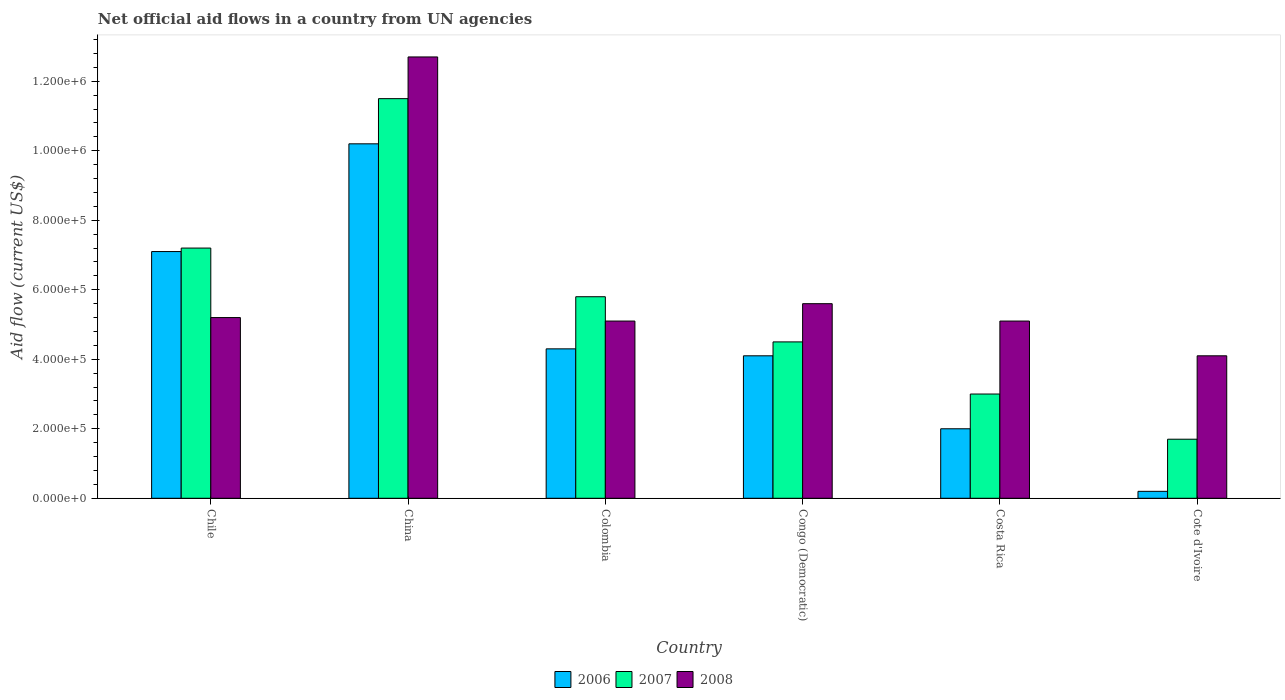Are the number of bars per tick equal to the number of legend labels?
Offer a terse response. Yes. What is the label of the 6th group of bars from the left?
Provide a succinct answer. Cote d'Ivoire. What is the net official aid flow in 2007 in Congo (Democratic)?
Your answer should be compact. 4.50e+05. Across all countries, what is the maximum net official aid flow in 2007?
Your response must be concise. 1.15e+06. In which country was the net official aid flow in 2007 minimum?
Keep it short and to the point. Cote d'Ivoire. What is the total net official aid flow in 2006 in the graph?
Offer a terse response. 2.79e+06. What is the difference between the net official aid flow in 2007 in Chile and the net official aid flow in 2008 in Costa Rica?
Your response must be concise. 2.10e+05. What is the average net official aid flow in 2007 per country?
Keep it short and to the point. 5.62e+05. What is the difference between the net official aid flow of/in 2007 and net official aid flow of/in 2008 in China?
Keep it short and to the point. -1.20e+05. In how many countries, is the net official aid flow in 2006 greater than 1280000 US$?
Keep it short and to the point. 0. Is the net official aid flow in 2006 in Colombia less than that in Congo (Democratic)?
Ensure brevity in your answer.  No. Is the difference between the net official aid flow in 2007 in Chile and Cote d'Ivoire greater than the difference between the net official aid flow in 2008 in Chile and Cote d'Ivoire?
Provide a short and direct response. Yes. What is the difference between the highest and the second highest net official aid flow in 2006?
Keep it short and to the point. 3.10e+05. What is the difference between the highest and the lowest net official aid flow in 2007?
Make the answer very short. 9.80e+05. What does the 2nd bar from the left in Congo (Democratic) represents?
Offer a very short reply. 2007. What does the 1st bar from the right in Colombia represents?
Ensure brevity in your answer.  2008. How many bars are there?
Offer a terse response. 18. Are all the bars in the graph horizontal?
Your answer should be compact. No. How many countries are there in the graph?
Your response must be concise. 6. Does the graph contain any zero values?
Ensure brevity in your answer.  No. Where does the legend appear in the graph?
Your answer should be compact. Bottom center. How are the legend labels stacked?
Provide a short and direct response. Horizontal. What is the title of the graph?
Offer a very short reply. Net official aid flows in a country from UN agencies. What is the Aid flow (current US$) of 2006 in Chile?
Keep it short and to the point. 7.10e+05. What is the Aid flow (current US$) in 2007 in Chile?
Your answer should be compact. 7.20e+05. What is the Aid flow (current US$) in 2008 in Chile?
Give a very brief answer. 5.20e+05. What is the Aid flow (current US$) in 2006 in China?
Provide a short and direct response. 1.02e+06. What is the Aid flow (current US$) in 2007 in China?
Your answer should be very brief. 1.15e+06. What is the Aid flow (current US$) of 2008 in China?
Ensure brevity in your answer.  1.27e+06. What is the Aid flow (current US$) in 2006 in Colombia?
Your answer should be very brief. 4.30e+05. What is the Aid flow (current US$) in 2007 in Colombia?
Your response must be concise. 5.80e+05. What is the Aid flow (current US$) of 2008 in Colombia?
Provide a succinct answer. 5.10e+05. What is the Aid flow (current US$) in 2008 in Congo (Democratic)?
Offer a terse response. 5.60e+05. What is the Aid flow (current US$) in 2006 in Costa Rica?
Your response must be concise. 2.00e+05. What is the Aid flow (current US$) of 2008 in Costa Rica?
Keep it short and to the point. 5.10e+05. What is the Aid flow (current US$) of 2008 in Cote d'Ivoire?
Your response must be concise. 4.10e+05. Across all countries, what is the maximum Aid flow (current US$) in 2006?
Provide a short and direct response. 1.02e+06. Across all countries, what is the maximum Aid flow (current US$) in 2007?
Your answer should be very brief. 1.15e+06. Across all countries, what is the maximum Aid flow (current US$) of 2008?
Provide a short and direct response. 1.27e+06. Across all countries, what is the minimum Aid flow (current US$) of 2006?
Your response must be concise. 2.00e+04. Across all countries, what is the minimum Aid flow (current US$) of 2007?
Your answer should be very brief. 1.70e+05. What is the total Aid flow (current US$) of 2006 in the graph?
Your response must be concise. 2.79e+06. What is the total Aid flow (current US$) of 2007 in the graph?
Keep it short and to the point. 3.37e+06. What is the total Aid flow (current US$) of 2008 in the graph?
Offer a very short reply. 3.78e+06. What is the difference between the Aid flow (current US$) in 2006 in Chile and that in China?
Offer a terse response. -3.10e+05. What is the difference between the Aid flow (current US$) of 2007 in Chile and that in China?
Your response must be concise. -4.30e+05. What is the difference between the Aid flow (current US$) in 2008 in Chile and that in China?
Keep it short and to the point. -7.50e+05. What is the difference between the Aid flow (current US$) of 2006 in Chile and that in Colombia?
Your answer should be compact. 2.80e+05. What is the difference between the Aid flow (current US$) in 2006 in Chile and that in Congo (Democratic)?
Keep it short and to the point. 3.00e+05. What is the difference between the Aid flow (current US$) in 2006 in Chile and that in Costa Rica?
Your response must be concise. 5.10e+05. What is the difference between the Aid flow (current US$) of 2008 in Chile and that in Costa Rica?
Offer a very short reply. 10000. What is the difference between the Aid flow (current US$) in 2006 in Chile and that in Cote d'Ivoire?
Offer a very short reply. 6.90e+05. What is the difference between the Aid flow (current US$) of 2007 in Chile and that in Cote d'Ivoire?
Keep it short and to the point. 5.50e+05. What is the difference between the Aid flow (current US$) in 2008 in Chile and that in Cote d'Ivoire?
Your answer should be very brief. 1.10e+05. What is the difference between the Aid flow (current US$) of 2006 in China and that in Colombia?
Make the answer very short. 5.90e+05. What is the difference between the Aid flow (current US$) in 2007 in China and that in Colombia?
Your response must be concise. 5.70e+05. What is the difference between the Aid flow (current US$) in 2008 in China and that in Colombia?
Ensure brevity in your answer.  7.60e+05. What is the difference between the Aid flow (current US$) of 2008 in China and that in Congo (Democratic)?
Offer a terse response. 7.10e+05. What is the difference between the Aid flow (current US$) of 2006 in China and that in Costa Rica?
Give a very brief answer. 8.20e+05. What is the difference between the Aid flow (current US$) in 2007 in China and that in Costa Rica?
Your answer should be very brief. 8.50e+05. What is the difference between the Aid flow (current US$) of 2008 in China and that in Costa Rica?
Keep it short and to the point. 7.60e+05. What is the difference between the Aid flow (current US$) in 2007 in China and that in Cote d'Ivoire?
Make the answer very short. 9.80e+05. What is the difference between the Aid flow (current US$) in 2008 in China and that in Cote d'Ivoire?
Offer a very short reply. 8.60e+05. What is the difference between the Aid flow (current US$) of 2006 in Colombia and that in Congo (Democratic)?
Give a very brief answer. 2.00e+04. What is the difference between the Aid flow (current US$) in 2008 in Colombia and that in Congo (Democratic)?
Your answer should be compact. -5.00e+04. What is the difference between the Aid flow (current US$) of 2007 in Colombia and that in Costa Rica?
Give a very brief answer. 2.80e+05. What is the difference between the Aid flow (current US$) in 2006 in Colombia and that in Cote d'Ivoire?
Provide a succinct answer. 4.10e+05. What is the difference between the Aid flow (current US$) of 2007 in Colombia and that in Cote d'Ivoire?
Make the answer very short. 4.10e+05. What is the difference between the Aid flow (current US$) in 2008 in Colombia and that in Cote d'Ivoire?
Provide a succinct answer. 1.00e+05. What is the difference between the Aid flow (current US$) of 2007 in Congo (Democratic) and that in Costa Rica?
Offer a very short reply. 1.50e+05. What is the difference between the Aid flow (current US$) of 2006 in Costa Rica and that in Cote d'Ivoire?
Offer a terse response. 1.80e+05. What is the difference between the Aid flow (current US$) of 2007 in Costa Rica and that in Cote d'Ivoire?
Your answer should be compact. 1.30e+05. What is the difference between the Aid flow (current US$) of 2008 in Costa Rica and that in Cote d'Ivoire?
Your answer should be very brief. 1.00e+05. What is the difference between the Aid flow (current US$) in 2006 in Chile and the Aid flow (current US$) in 2007 in China?
Provide a short and direct response. -4.40e+05. What is the difference between the Aid flow (current US$) in 2006 in Chile and the Aid flow (current US$) in 2008 in China?
Give a very brief answer. -5.60e+05. What is the difference between the Aid flow (current US$) in 2007 in Chile and the Aid flow (current US$) in 2008 in China?
Provide a succinct answer. -5.50e+05. What is the difference between the Aid flow (current US$) of 2006 in Chile and the Aid flow (current US$) of 2007 in Colombia?
Make the answer very short. 1.30e+05. What is the difference between the Aid flow (current US$) of 2006 in Chile and the Aid flow (current US$) of 2008 in Colombia?
Keep it short and to the point. 2.00e+05. What is the difference between the Aid flow (current US$) in 2007 in Chile and the Aid flow (current US$) in 2008 in Congo (Democratic)?
Your answer should be very brief. 1.60e+05. What is the difference between the Aid flow (current US$) of 2007 in Chile and the Aid flow (current US$) of 2008 in Costa Rica?
Give a very brief answer. 2.10e+05. What is the difference between the Aid flow (current US$) in 2006 in Chile and the Aid flow (current US$) in 2007 in Cote d'Ivoire?
Your answer should be very brief. 5.40e+05. What is the difference between the Aid flow (current US$) of 2006 in Chile and the Aid flow (current US$) of 2008 in Cote d'Ivoire?
Keep it short and to the point. 3.00e+05. What is the difference between the Aid flow (current US$) in 2006 in China and the Aid flow (current US$) in 2008 in Colombia?
Your answer should be very brief. 5.10e+05. What is the difference between the Aid flow (current US$) of 2007 in China and the Aid flow (current US$) of 2008 in Colombia?
Provide a succinct answer. 6.40e+05. What is the difference between the Aid flow (current US$) of 2006 in China and the Aid flow (current US$) of 2007 in Congo (Democratic)?
Ensure brevity in your answer.  5.70e+05. What is the difference between the Aid flow (current US$) of 2007 in China and the Aid flow (current US$) of 2008 in Congo (Democratic)?
Make the answer very short. 5.90e+05. What is the difference between the Aid flow (current US$) in 2006 in China and the Aid flow (current US$) in 2007 in Costa Rica?
Offer a very short reply. 7.20e+05. What is the difference between the Aid flow (current US$) in 2006 in China and the Aid flow (current US$) in 2008 in Costa Rica?
Your answer should be very brief. 5.10e+05. What is the difference between the Aid flow (current US$) in 2007 in China and the Aid flow (current US$) in 2008 in Costa Rica?
Ensure brevity in your answer.  6.40e+05. What is the difference between the Aid flow (current US$) of 2006 in China and the Aid flow (current US$) of 2007 in Cote d'Ivoire?
Your response must be concise. 8.50e+05. What is the difference between the Aid flow (current US$) in 2007 in China and the Aid flow (current US$) in 2008 in Cote d'Ivoire?
Provide a succinct answer. 7.40e+05. What is the difference between the Aid flow (current US$) of 2006 in Colombia and the Aid flow (current US$) of 2007 in Congo (Democratic)?
Ensure brevity in your answer.  -2.00e+04. What is the difference between the Aid flow (current US$) of 2006 in Colombia and the Aid flow (current US$) of 2008 in Congo (Democratic)?
Provide a succinct answer. -1.30e+05. What is the difference between the Aid flow (current US$) in 2007 in Colombia and the Aid flow (current US$) in 2008 in Congo (Democratic)?
Provide a succinct answer. 2.00e+04. What is the difference between the Aid flow (current US$) of 2007 in Colombia and the Aid flow (current US$) of 2008 in Costa Rica?
Ensure brevity in your answer.  7.00e+04. What is the difference between the Aid flow (current US$) in 2006 in Colombia and the Aid flow (current US$) in 2008 in Cote d'Ivoire?
Provide a short and direct response. 2.00e+04. What is the difference between the Aid flow (current US$) in 2006 in Congo (Democratic) and the Aid flow (current US$) in 2007 in Cote d'Ivoire?
Ensure brevity in your answer.  2.40e+05. What is the difference between the Aid flow (current US$) in 2007 in Congo (Democratic) and the Aid flow (current US$) in 2008 in Cote d'Ivoire?
Provide a short and direct response. 4.00e+04. What is the difference between the Aid flow (current US$) in 2006 in Costa Rica and the Aid flow (current US$) in 2007 in Cote d'Ivoire?
Offer a terse response. 3.00e+04. What is the average Aid flow (current US$) in 2006 per country?
Give a very brief answer. 4.65e+05. What is the average Aid flow (current US$) in 2007 per country?
Provide a short and direct response. 5.62e+05. What is the average Aid flow (current US$) in 2008 per country?
Provide a short and direct response. 6.30e+05. What is the difference between the Aid flow (current US$) of 2006 and Aid flow (current US$) of 2007 in China?
Your answer should be very brief. -1.30e+05. What is the difference between the Aid flow (current US$) in 2006 and Aid flow (current US$) in 2008 in China?
Provide a short and direct response. -2.50e+05. What is the difference between the Aid flow (current US$) of 2007 and Aid flow (current US$) of 2008 in China?
Your answer should be compact. -1.20e+05. What is the difference between the Aid flow (current US$) of 2006 and Aid flow (current US$) of 2007 in Colombia?
Give a very brief answer. -1.50e+05. What is the difference between the Aid flow (current US$) in 2007 and Aid flow (current US$) in 2008 in Colombia?
Provide a succinct answer. 7.00e+04. What is the difference between the Aid flow (current US$) of 2006 and Aid flow (current US$) of 2007 in Congo (Democratic)?
Make the answer very short. -4.00e+04. What is the difference between the Aid flow (current US$) of 2006 and Aid flow (current US$) of 2007 in Costa Rica?
Provide a succinct answer. -1.00e+05. What is the difference between the Aid flow (current US$) of 2006 and Aid flow (current US$) of 2008 in Costa Rica?
Your answer should be compact. -3.10e+05. What is the difference between the Aid flow (current US$) in 2007 and Aid flow (current US$) in 2008 in Costa Rica?
Provide a short and direct response. -2.10e+05. What is the difference between the Aid flow (current US$) in 2006 and Aid flow (current US$) in 2008 in Cote d'Ivoire?
Offer a very short reply. -3.90e+05. What is the ratio of the Aid flow (current US$) of 2006 in Chile to that in China?
Provide a succinct answer. 0.7. What is the ratio of the Aid flow (current US$) of 2007 in Chile to that in China?
Make the answer very short. 0.63. What is the ratio of the Aid flow (current US$) of 2008 in Chile to that in China?
Offer a very short reply. 0.41. What is the ratio of the Aid flow (current US$) of 2006 in Chile to that in Colombia?
Give a very brief answer. 1.65. What is the ratio of the Aid flow (current US$) of 2007 in Chile to that in Colombia?
Keep it short and to the point. 1.24. What is the ratio of the Aid flow (current US$) of 2008 in Chile to that in Colombia?
Offer a very short reply. 1.02. What is the ratio of the Aid flow (current US$) of 2006 in Chile to that in Congo (Democratic)?
Make the answer very short. 1.73. What is the ratio of the Aid flow (current US$) in 2007 in Chile to that in Congo (Democratic)?
Offer a very short reply. 1.6. What is the ratio of the Aid flow (current US$) of 2008 in Chile to that in Congo (Democratic)?
Offer a terse response. 0.93. What is the ratio of the Aid flow (current US$) of 2006 in Chile to that in Costa Rica?
Your answer should be very brief. 3.55. What is the ratio of the Aid flow (current US$) in 2008 in Chile to that in Costa Rica?
Offer a very short reply. 1.02. What is the ratio of the Aid flow (current US$) of 2006 in Chile to that in Cote d'Ivoire?
Your response must be concise. 35.5. What is the ratio of the Aid flow (current US$) in 2007 in Chile to that in Cote d'Ivoire?
Keep it short and to the point. 4.24. What is the ratio of the Aid flow (current US$) of 2008 in Chile to that in Cote d'Ivoire?
Provide a short and direct response. 1.27. What is the ratio of the Aid flow (current US$) in 2006 in China to that in Colombia?
Your response must be concise. 2.37. What is the ratio of the Aid flow (current US$) in 2007 in China to that in Colombia?
Your answer should be compact. 1.98. What is the ratio of the Aid flow (current US$) of 2008 in China to that in Colombia?
Your response must be concise. 2.49. What is the ratio of the Aid flow (current US$) in 2006 in China to that in Congo (Democratic)?
Your answer should be very brief. 2.49. What is the ratio of the Aid flow (current US$) of 2007 in China to that in Congo (Democratic)?
Your answer should be very brief. 2.56. What is the ratio of the Aid flow (current US$) of 2008 in China to that in Congo (Democratic)?
Offer a terse response. 2.27. What is the ratio of the Aid flow (current US$) in 2006 in China to that in Costa Rica?
Provide a short and direct response. 5.1. What is the ratio of the Aid flow (current US$) of 2007 in China to that in Costa Rica?
Ensure brevity in your answer.  3.83. What is the ratio of the Aid flow (current US$) in 2008 in China to that in Costa Rica?
Keep it short and to the point. 2.49. What is the ratio of the Aid flow (current US$) of 2007 in China to that in Cote d'Ivoire?
Make the answer very short. 6.76. What is the ratio of the Aid flow (current US$) of 2008 in China to that in Cote d'Ivoire?
Your response must be concise. 3.1. What is the ratio of the Aid flow (current US$) of 2006 in Colombia to that in Congo (Democratic)?
Keep it short and to the point. 1.05. What is the ratio of the Aid flow (current US$) in 2007 in Colombia to that in Congo (Democratic)?
Your answer should be compact. 1.29. What is the ratio of the Aid flow (current US$) in 2008 in Colombia to that in Congo (Democratic)?
Your answer should be compact. 0.91. What is the ratio of the Aid flow (current US$) in 2006 in Colombia to that in Costa Rica?
Your answer should be very brief. 2.15. What is the ratio of the Aid flow (current US$) in 2007 in Colombia to that in Costa Rica?
Your response must be concise. 1.93. What is the ratio of the Aid flow (current US$) of 2008 in Colombia to that in Costa Rica?
Keep it short and to the point. 1. What is the ratio of the Aid flow (current US$) of 2006 in Colombia to that in Cote d'Ivoire?
Offer a very short reply. 21.5. What is the ratio of the Aid flow (current US$) of 2007 in Colombia to that in Cote d'Ivoire?
Make the answer very short. 3.41. What is the ratio of the Aid flow (current US$) in 2008 in Colombia to that in Cote d'Ivoire?
Provide a succinct answer. 1.24. What is the ratio of the Aid flow (current US$) in 2006 in Congo (Democratic) to that in Costa Rica?
Your answer should be very brief. 2.05. What is the ratio of the Aid flow (current US$) in 2007 in Congo (Democratic) to that in Costa Rica?
Your answer should be compact. 1.5. What is the ratio of the Aid flow (current US$) of 2008 in Congo (Democratic) to that in Costa Rica?
Your answer should be compact. 1.1. What is the ratio of the Aid flow (current US$) in 2006 in Congo (Democratic) to that in Cote d'Ivoire?
Make the answer very short. 20.5. What is the ratio of the Aid flow (current US$) of 2007 in Congo (Democratic) to that in Cote d'Ivoire?
Offer a very short reply. 2.65. What is the ratio of the Aid flow (current US$) in 2008 in Congo (Democratic) to that in Cote d'Ivoire?
Ensure brevity in your answer.  1.37. What is the ratio of the Aid flow (current US$) in 2007 in Costa Rica to that in Cote d'Ivoire?
Your response must be concise. 1.76. What is the ratio of the Aid flow (current US$) of 2008 in Costa Rica to that in Cote d'Ivoire?
Provide a short and direct response. 1.24. What is the difference between the highest and the second highest Aid flow (current US$) in 2006?
Make the answer very short. 3.10e+05. What is the difference between the highest and the second highest Aid flow (current US$) of 2007?
Your answer should be compact. 4.30e+05. What is the difference between the highest and the second highest Aid flow (current US$) of 2008?
Give a very brief answer. 7.10e+05. What is the difference between the highest and the lowest Aid flow (current US$) of 2007?
Offer a very short reply. 9.80e+05. What is the difference between the highest and the lowest Aid flow (current US$) of 2008?
Your answer should be very brief. 8.60e+05. 